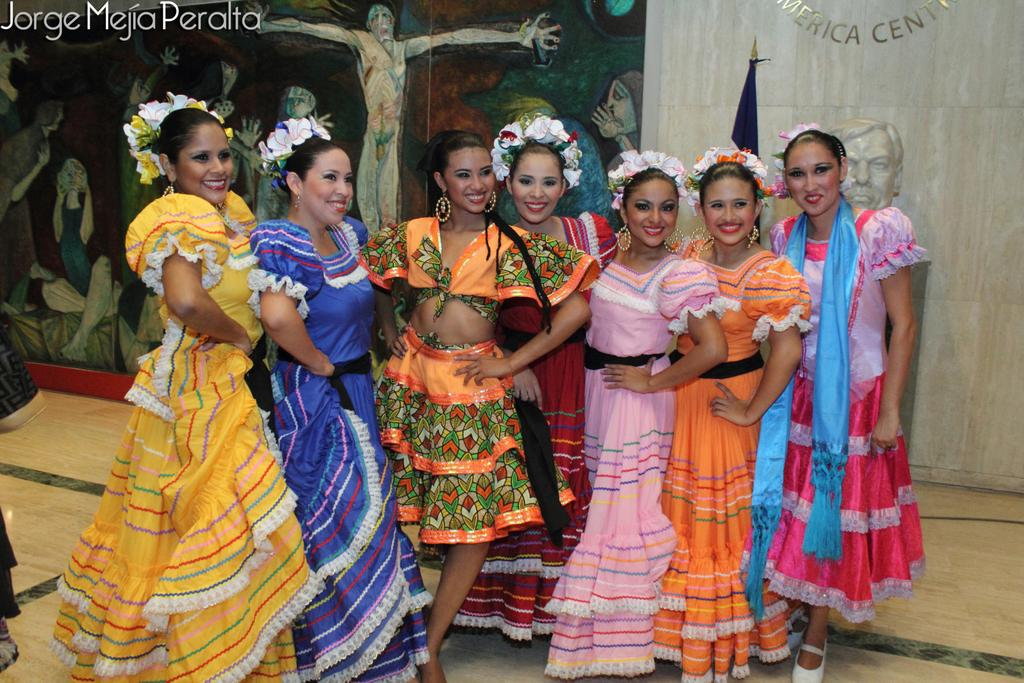What is happening in the front of the image? There is a group of people standing in the front of the image. What can be seen in the background of the image? There is a banner, a flag, and a white color wall in the background of the image. Is there any blood visible on the banner in the image? There is no blood present in the image. Can you tell me how many times the flag turns in the image? The flag does not turn in the image; it is stationary. 